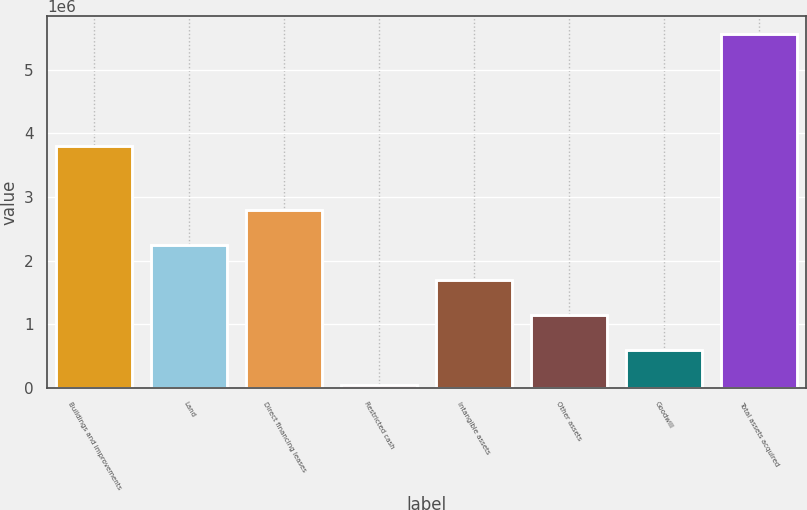<chart> <loc_0><loc_0><loc_500><loc_500><bar_chart><fcel>Buildings and improvements<fcel>Land<fcel>Direct financing leases<fcel>Restricted cash<fcel>Intangible assets<fcel>Other assets<fcel>Goodwill<fcel>Total assets acquired<nl><fcel>3.79505e+06<fcel>2.24594e+06<fcel>2.79879e+06<fcel>34566<fcel>1.6931e+06<fcel>1.14026e+06<fcel>587411<fcel>5.56301e+06<nl></chart> 